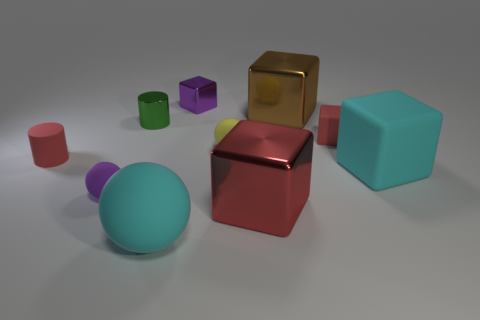How many tiny cylinders have the same material as the green thing?
Your answer should be very brief. 0. Is the number of purple matte balls less than the number of tiny cylinders?
Your answer should be compact. Yes. Do the red thing to the right of the red shiny thing and the large brown block have the same material?
Your answer should be compact. No. How many cylinders are either tiny purple metallic objects or tiny yellow things?
Your response must be concise. 0. The red thing that is both on the right side of the tiny purple sphere and behind the cyan rubber block has what shape?
Your answer should be compact. Cube. The big metal thing that is in front of the tiny cylinder right of the tiny cylinder on the left side of the tiny purple rubber thing is what color?
Keep it short and to the point. Red. Is the number of metal blocks in front of the tiny yellow object less than the number of big rubber things?
Offer a terse response. Yes. Is the shape of the cyan object that is behind the tiny purple sphere the same as the large metal thing behind the cyan block?
Give a very brief answer. Yes. What number of objects are big matte objects behind the large red metallic block or cyan matte cubes?
Provide a short and direct response. 1. What is the material of the small object that is the same color as the rubber cylinder?
Provide a short and direct response. Rubber. 